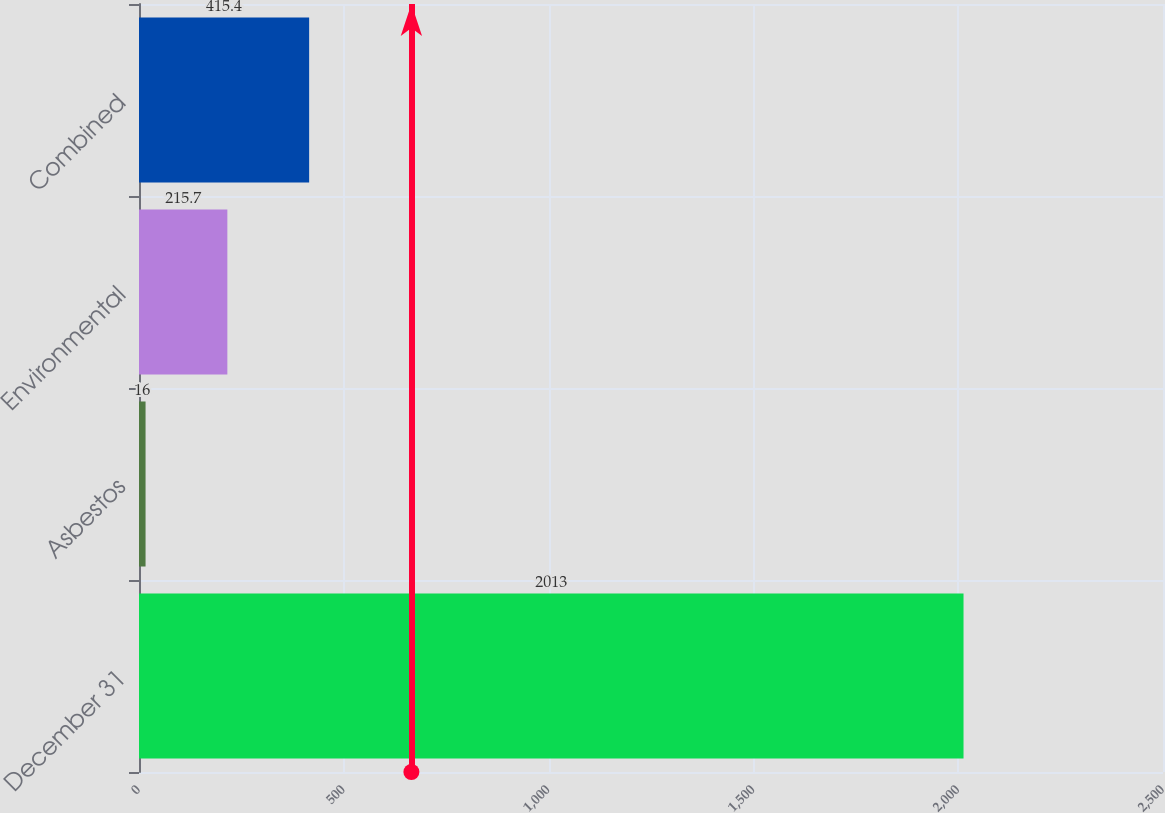Convert chart to OTSL. <chart><loc_0><loc_0><loc_500><loc_500><bar_chart><fcel>December 31<fcel>Asbestos<fcel>Environmental<fcel>Combined<nl><fcel>2013<fcel>16<fcel>215.7<fcel>415.4<nl></chart> 